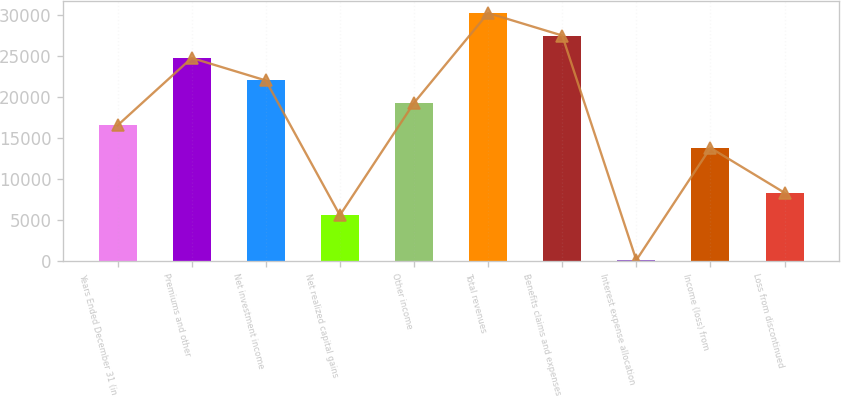Convert chart to OTSL. <chart><loc_0><loc_0><loc_500><loc_500><bar_chart><fcel>Years Ended December 31 (in<fcel>Premiums and other<fcel>Net investment income<fcel>Net realized capital gains<fcel>Other income<fcel>Total revenues<fcel>Benefits claims and expenses<fcel>Interest expense allocation<fcel>Income (loss) from<fcel>Loss from discontinued<nl><fcel>16560.2<fcel>24795.8<fcel>22050.6<fcel>5579.4<fcel>19305.4<fcel>30286.2<fcel>27541<fcel>89<fcel>13815<fcel>8324.6<nl></chart> 